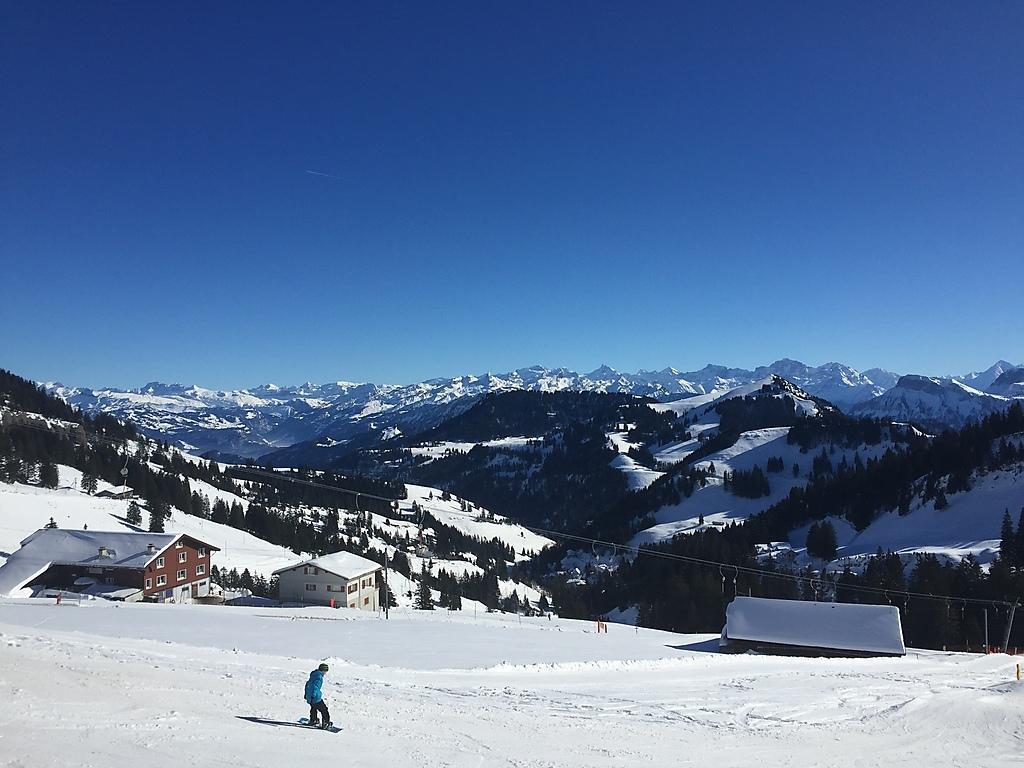How would you summarize this image in a sentence or two? In this image I see a person over here and I see few buildings and I see the snow. In the background I see number of trees and I see the mountains and I see the clear sky. 